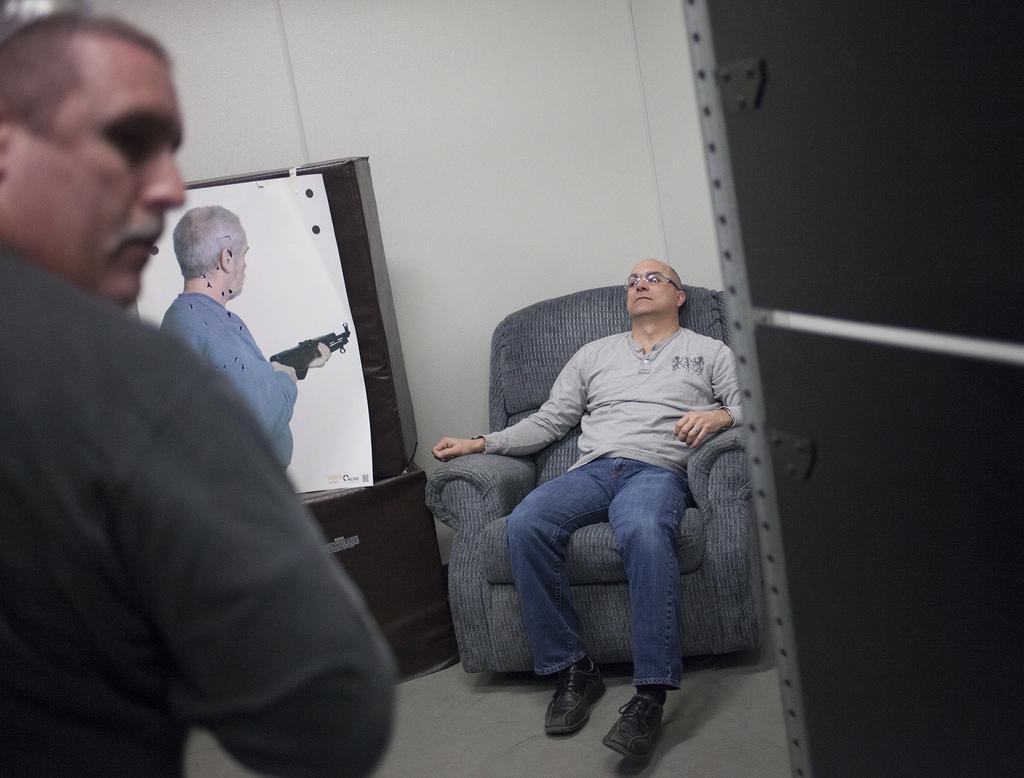In one or two sentences, can you explain what this image depicts? In this image i can see man sitting on a couch, at the left there are two man standing, a man standing here is holding a gun, at the back ground i can see a wall. 